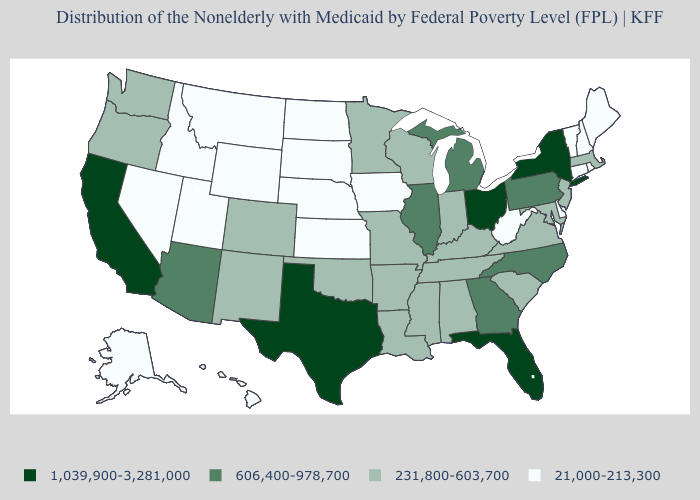Does the first symbol in the legend represent the smallest category?
Short answer required. No. What is the lowest value in the Northeast?
Answer briefly. 21,000-213,300. What is the value of Ohio?
Concise answer only. 1,039,900-3,281,000. What is the value of New Jersey?
Answer briefly. 231,800-603,700. Among the states that border North Dakota , which have the highest value?
Answer briefly. Minnesota. What is the lowest value in the South?
Be succinct. 21,000-213,300. What is the value of Alabama?
Quick response, please. 231,800-603,700. What is the value of Montana?
Write a very short answer. 21,000-213,300. Name the states that have a value in the range 1,039,900-3,281,000?
Quick response, please. California, Florida, New York, Ohio, Texas. Name the states that have a value in the range 1,039,900-3,281,000?
Give a very brief answer. California, Florida, New York, Ohio, Texas. Name the states that have a value in the range 1,039,900-3,281,000?
Answer briefly. California, Florida, New York, Ohio, Texas. Name the states that have a value in the range 1,039,900-3,281,000?
Answer briefly. California, Florida, New York, Ohio, Texas. What is the value of Minnesota?
Keep it brief. 231,800-603,700. Name the states that have a value in the range 606,400-978,700?
Write a very short answer. Arizona, Georgia, Illinois, Michigan, North Carolina, Pennsylvania. What is the value of North Carolina?
Keep it brief. 606,400-978,700. 